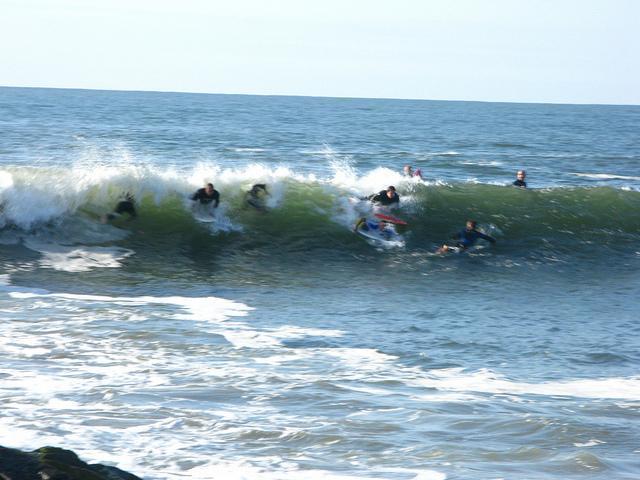What are the surfers in a push up position attempting to do?
Indicate the correct response and explain using: 'Answer: answer
Rationale: rationale.'
Options: Exercise, stand, roll, dive. Answer: stand.
Rationale: The surfers want to stand up on the boards. 